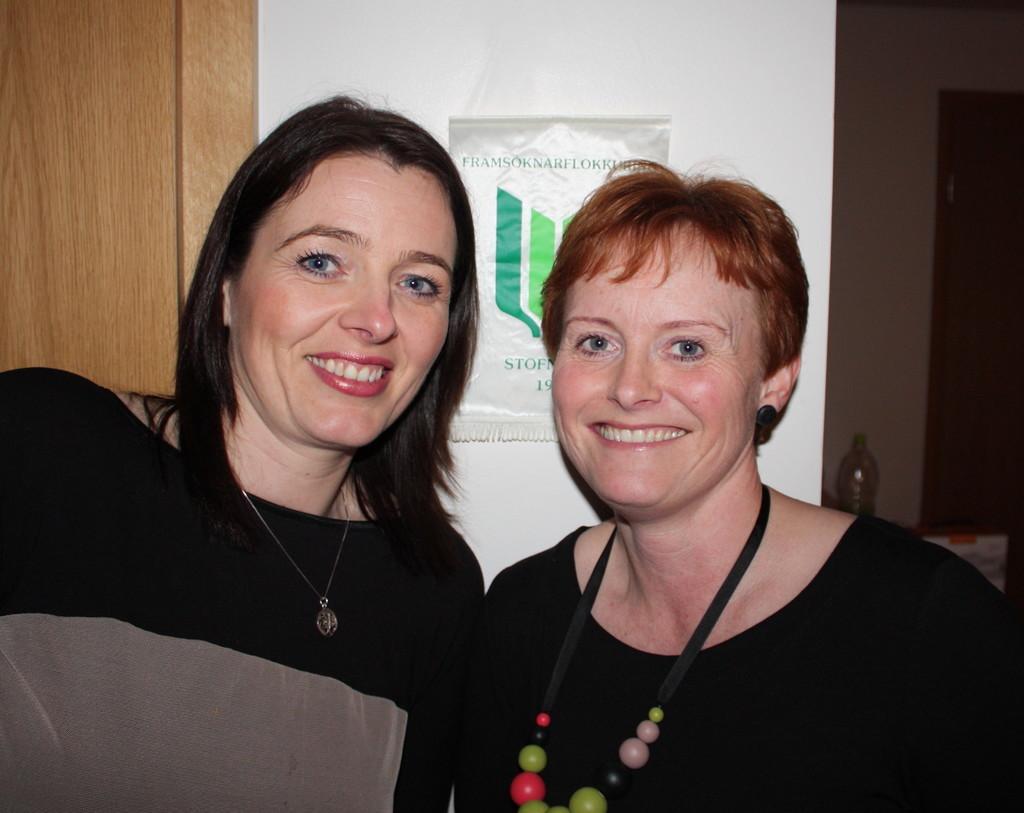Describe this image in one or two sentences. In this picture there are two people smiling. At the back there is a poster on the wall, there is text on the poster. On the right side of the image there is a bottle on the table and there is a door. On the left side of the image it looks like a door. 